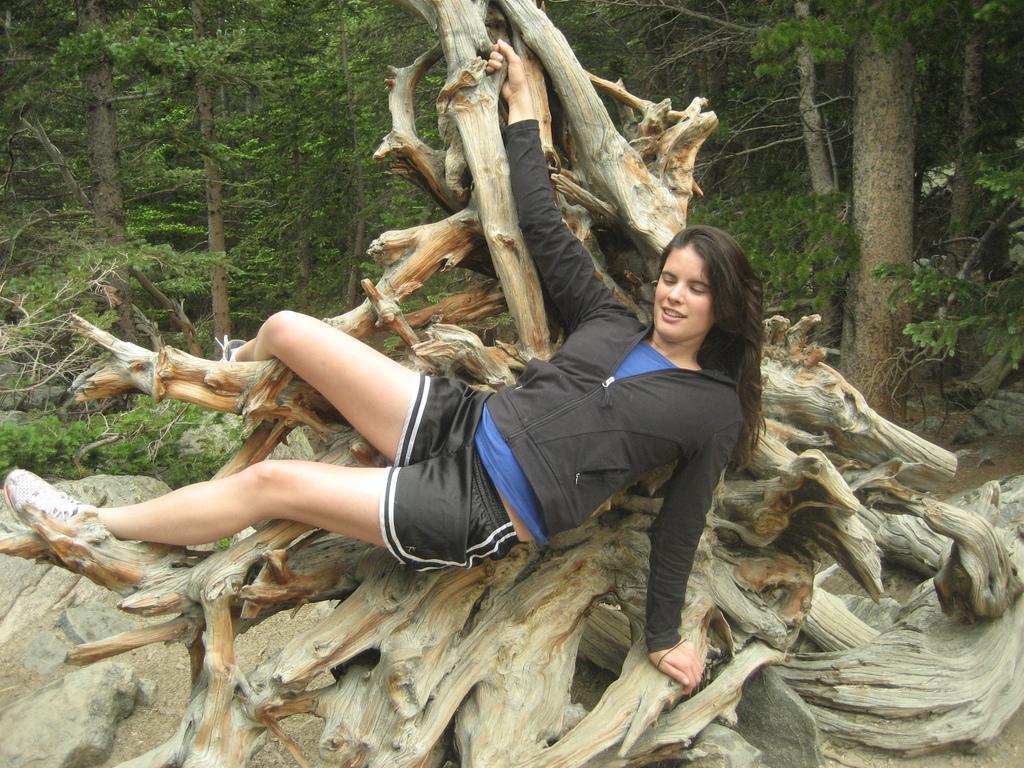Could you give a brief overview of what you see in this image? In this image we can see a lady lying on the trunk, there are plants, rocks, and trees. 